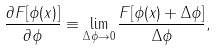<formula> <loc_0><loc_0><loc_500><loc_500>\frac { \partial F [ \phi ( x ) ] } { \partial \phi } \equiv \lim _ { \Delta \phi \rightarrow 0 } \frac { F [ \phi ( x ) + \Delta \phi ] } { \Delta \phi } ,</formula> 